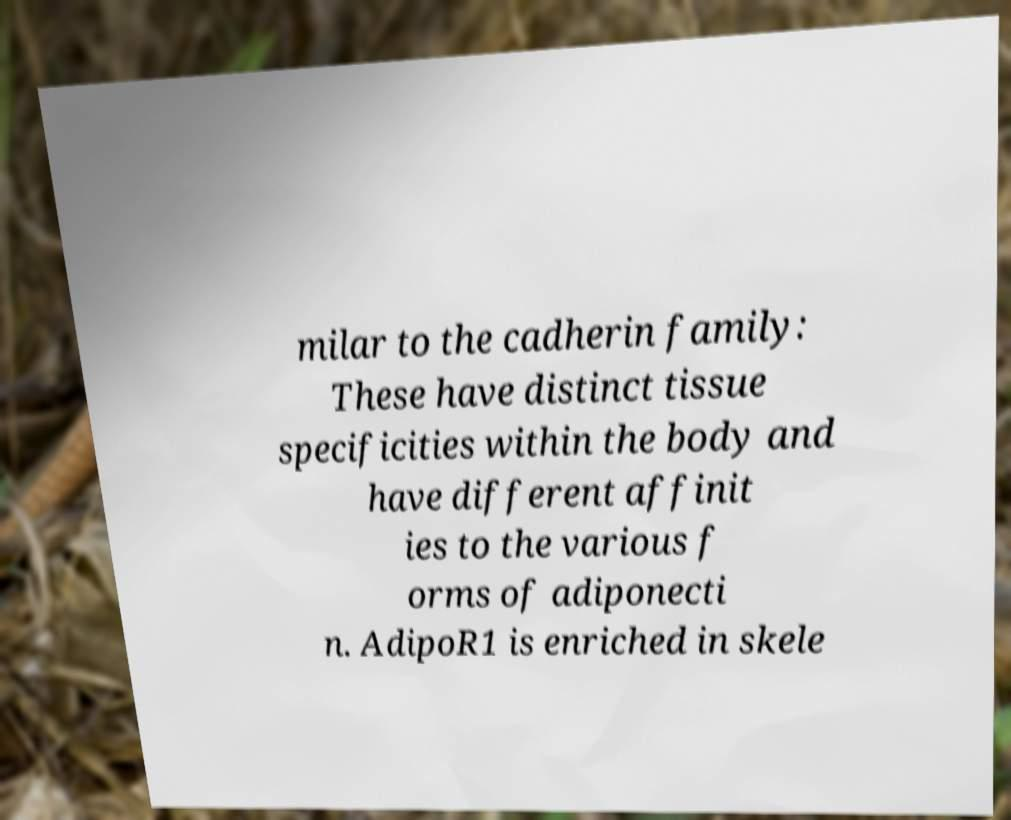What messages or text are displayed in this image? I need them in a readable, typed format. milar to the cadherin family: These have distinct tissue specificities within the body and have different affinit ies to the various f orms of adiponecti n. AdipoR1 is enriched in skele 